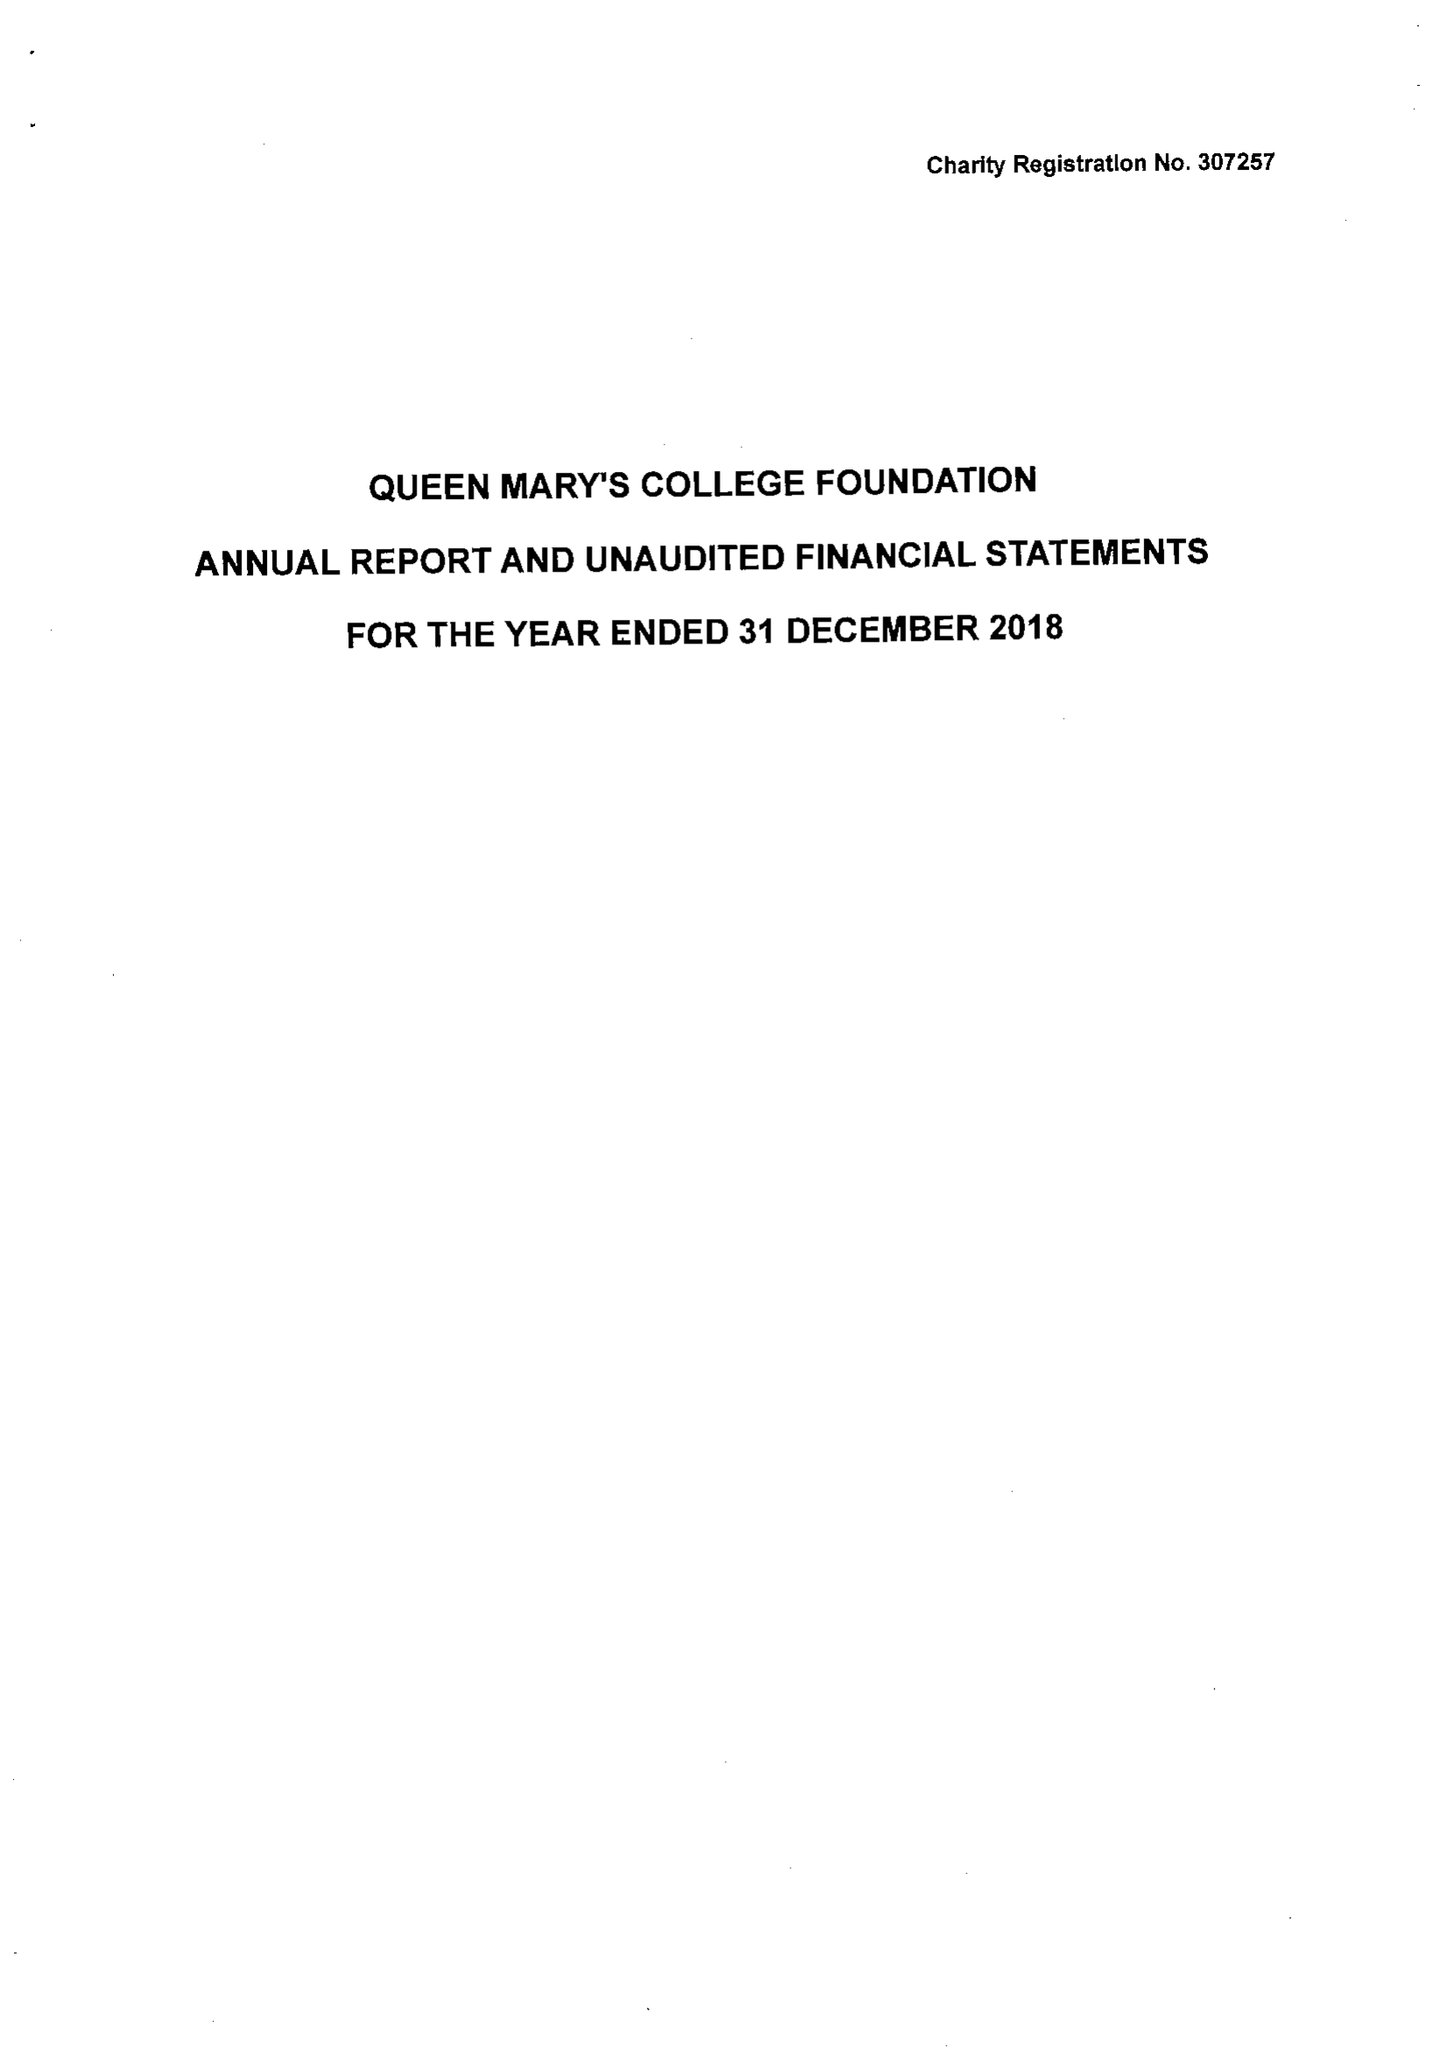What is the value for the spending_annually_in_british_pounds?
Answer the question using a single word or phrase. 36671.00 